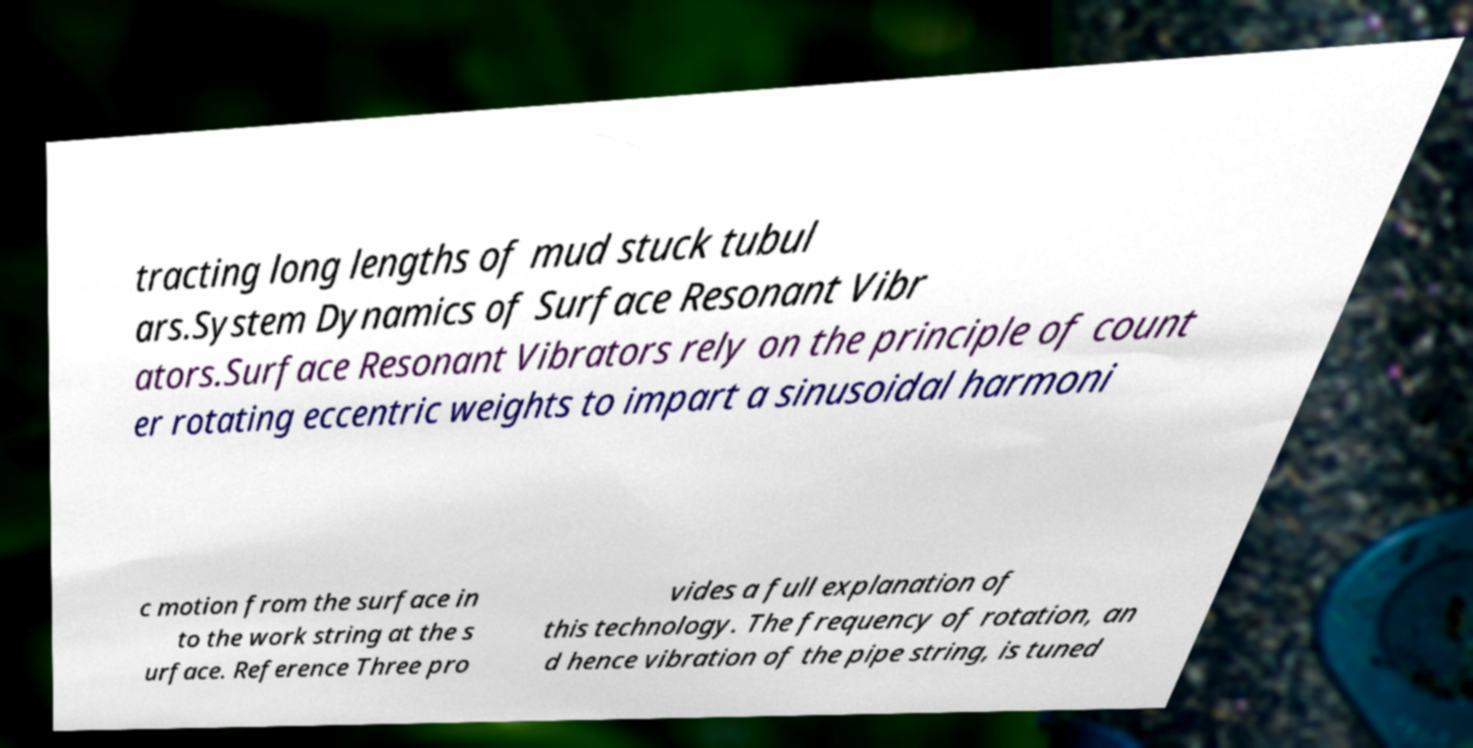For documentation purposes, I need the text within this image transcribed. Could you provide that? tracting long lengths of mud stuck tubul ars.System Dynamics of Surface Resonant Vibr ators.Surface Resonant Vibrators rely on the principle of count er rotating eccentric weights to impart a sinusoidal harmoni c motion from the surface in to the work string at the s urface. Reference Three pro vides a full explanation of this technology. The frequency of rotation, an d hence vibration of the pipe string, is tuned 